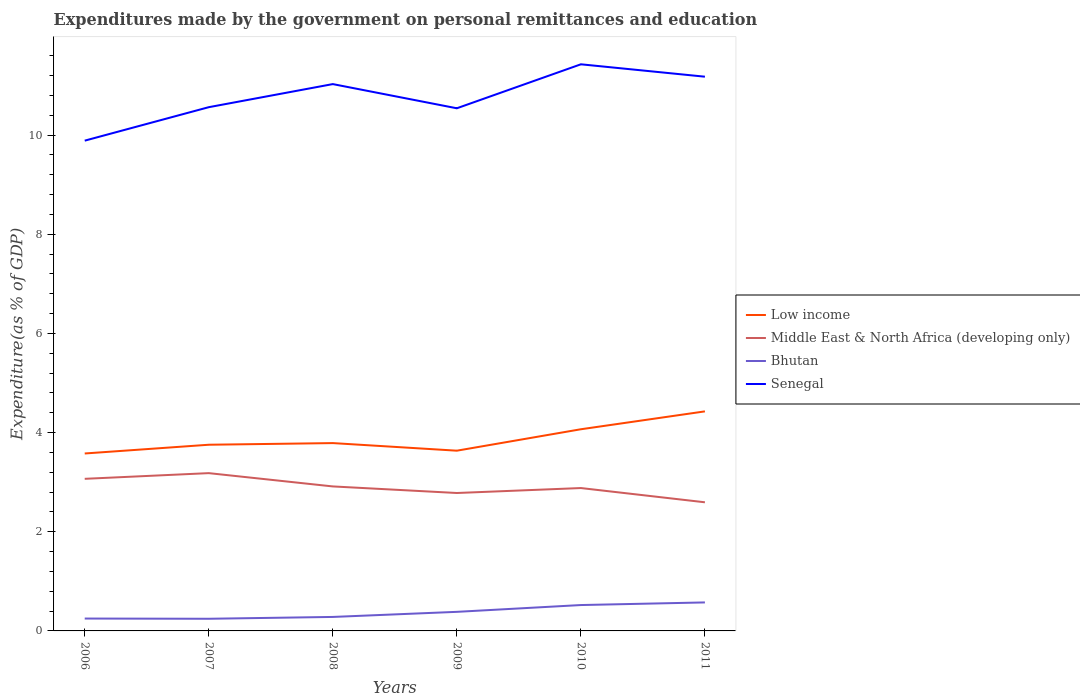Does the line corresponding to Middle East & North Africa (developing only) intersect with the line corresponding to Senegal?
Your answer should be very brief. No. Across all years, what is the maximum expenditures made by the government on personal remittances and education in Middle East & North Africa (developing only)?
Your answer should be very brief. 2.59. What is the total expenditures made by the government on personal remittances and education in Low income in the graph?
Offer a very short reply. -0.28. What is the difference between the highest and the second highest expenditures made by the government on personal remittances and education in Senegal?
Give a very brief answer. 1.54. What is the difference between the highest and the lowest expenditures made by the government on personal remittances and education in Middle East & North Africa (developing only)?
Your response must be concise. 3. How many years are there in the graph?
Your answer should be compact. 6. What is the difference between two consecutive major ticks on the Y-axis?
Your answer should be very brief. 2. Are the values on the major ticks of Y-axis written in scientific E-notation?
Your response must be concise. No. Does the graph contain grids?
Provide a short and direct response. No. How many legend labels are there?
Your answer should be very brief. 4. What is the title of the graph?
Provide a short and direct response. Expenditures made by the government on personal remittances and education. What is the label or title of the X-axis?
Give a very brief answer. Years. What is the label or title of the Y-axis?
Your response must be concise. Expenditure(as % of GDP). What is the Expenditure(as % of GDP) of Low income in 2006?
Offer a terse response. 3.58. What is the Expenditure(as % of GDP) in Middle East & North Africa (developing only) in 2006?
Your response must be concise. 3.07. What is the Expenditure(as % of GDP) of Bhutan in 2006?
Offer a very short reply. 0.25. What is the Expenditure(as % of GDP) in Senegal in 2006?
Keep it short and to the point. 9.89. What is the Expenditure(as % of GDP) in Low income in 2007?
Offer a terse response. 3.75. What is the Expenditure(as % of GDP) of Middle East & North Africa (developing only) in 2007?
Provide a succinct answer. 3.18. What is the Expenditure(as % of GDP) in Bhutan in 2007?
Your response must be concise. 0.25. What is the Expenditure(as % of GDP) of Senegal in 2007?
Your response must be concise. 10.56. What is the Expenditure(as % of GDP) of Low income in 2008?
Ensure brevity in your answer.  3.79. What is the Expenditure(as % of GDP) of Middle East & North Africa (developing only) in 2008?
Your response must be concise. 2.91. What is the Expenditure(as % of GDP) in Bhutan in 2008?
Ensure brevity in your answer.  0.28. What is the Expenditure(as % of GDP) in Senegal in 2008?
Give a very brief answer. 11.03. What is the Expenditure(as % of GDP) of Low income in 2009?
Keep it short and to the point. 3.63. What is the Expenditure(as % of GDP) of Middle East & North Africa (developing only) in 2009?
Ensure brevity in your answer.  2.78. What is the Expenditure(as % of GDP) of Bhutan in 2009?
Offer a terse response. 0.38. What is the Expenditure(as % of GDP) of Senegal in 2009?
Ensure brevity in your answer.  10.54. What is the Expenditure(as % of GDP) in Low income in 2010?
Provide a short and direct response. 4.07. What is the Expenditure(as % of GDP) of Middle East & North Africa (developing only) in 2010?
Provide a short and direct response. 2.88. What is the Expenditure(as % of GDP) of Bhutan in 2010?
Your answer should be compact. 0.52. What is the Expenditure(as % of GDP) in Senegal in 2010?
Your response must be concise. 11.43. What is the Expenditure(as % of GDP) of Low income in 2011?
Your answer should be very brief. 4.43. What is the Expenditure(as % of GDP) of Middle East & North Africa (developing only) in 2011?
Your answer should be very brief. 2.59. What is the Expenditure(as % of GDP) of Bhutan in 2011?
Ensure brevity in your answer.  0.57. What is the Expenditure(as % of GDP) in Senegal in 2011?
Make the answer very short. 11.18. Across all years, what is the maximum Expenditure(as % of GDP) in Low income?
Your answer should be compact. 4.43. Across all years, what is the maximum Expenditure(as % of GDP) in Middle East & North Africa (developing only)?
Give a very brief answer. 3.18. Across all years, what is the maximum Expenditure(as % of GDP) of Bhutan?
Ensure brevity in your answer.  0.57. Across all years, what is the maximum Expenditure(as % of GDP) of Senegal?
Provide a succinct answer. 11.43. Across all years, what is the minimum Expenditure(as % of GDP) in Low income?
Keep it short and to the point. 3.58. Across all years, what is the minimum Expenditure(as % of GDP) in Middle East & North Africa (developing only)?
Offer a very short reply. 2.59. Across all years, what is the minimum Expenditure(as % of GDP) in Bhutan?
Ensure brevity in your answer.  0.25. Across all years, what is the minimum Expenditure(as % of GDP) in Senegal?
Ensure brevity in your answer.  9.89. What is the total Expenditure(as % of GDP) in Low income in the graph?
Your answer should be compact. 23.25. What is the total Expenditure(as % of GDP) of Middle East & North Africa (developing only) in the graph?
Provide a short and direct response. 17.42. What is the total Expenditure(as % of GDP) of Bhutan in the graph?
Keep it short and to the point. 2.26. What is the total Expenditure(as % of GDP) of Senegal in the graph?
Your response must be concise. 64.62. What is the difference between the Expenditure(as % of GDP) of Low income in 2006 and that in 2007?
Your answer should be very brief. -0.18. What is the difference between the Expenditure(as % of GDP) of Middle East & North Africa (developing only) in 2006 and that in 2007?
Make the answer very short. -0.11. What is the difference between the Expenditure(as % of GDP) in Bhutan in 2006 and that in 2007?
Give a very brief answer. 0. What is the difference between the Expenditure(as % of GDP) of Senegal in 2006 and that in 2007?
Provide a short and direct response. -0.67. What is the difference between the Expenditure(as % of GDP) in Low income in 2006 and that in 2008?
Your response must be concise. -0.21. What is the difference between the Expenditure(as % of GDP) in Middle East & North Africa (developing only) in 2006 and that in 2008?
Provide a succinct answer. 0.15. What is the difference between the Expenditure(as % of GDP) of Bhutan in 2006 and that in 2008?
Your response must be concise. -0.03. What is the difference between the Expenditure(as % of GDP) of Senegal in 2006 and that in 2008?
Offer a terse response. -1.14. What is the difference between the Expenditure(as % of GDP) in Low income in 2006 and that in 2009?
Offer a very short reply. -0.06. What is the difference between the Expenditure(as % of GDP) in Middle East & North Africa (developing only) in 2006 and that in 2009?
Provide a succinct answer. 0.29. What is the difference between the Expenditure(as % of GDP) of Bhutan in 2006 and that in 2009?
Give a very brief answer. -0.14. What is the difference between the Expenditure(as % of GDP) of Senegal in 2006 and that in 2009?
Your answer should be very brief. -0.65. What is the difference between the Expenditure(as % of GDP) of Low income in 2006 and that in 2010?
Your answer should be compact. -0.49. What is the difference between the Expenditure(as % of GDP) of Middle East & North Africa (developing only) in 2006 and that in 2010?
Ensure brevity in your answer.  0.19. What is the difference between the Expenditure(as % of GDP) in Bhutan in 2006 and that in 2010?
Ensure brevity in your answer.  -0.27. What is the difference between the Expenditure(as % of GDP) in Senegal in 2006 and that in 2010?
Your answer should be very brief. -1.54. What is the difference between the Expenditure(as % of GDP) in Low income in 2006 and that in 2011?
Give a very brief answer. -0.85. What is the difference between the Expenditure(as % of GDP) of Middle East & North Africa (developing only) in 2006 and that in 2011?
Give a very brief answer. 0.47. What is the difference between the Expenditure(as % of GDP) of Bhutan in 2006 and that in 2011?
Keep it short and to the point. -0.33. What is the difference between the Expenditure(as % of GDP) in Senegal in 2006 and that in 2011?
Your answer should be very brief. -1.29. What is the difference between the Expenditure(as % of GDP) in Low income in 2007 and that in 2008?
Provide a short and direct response. -0.03. What is the difference between the Expenditure(as % of GDP) of Middle East & North Africa (developing only) in 2007 and that in 2008?
Keep it short and to the point. 0.27. What is the difference between the Expenditure(as % of GDP) in Bhutan in 2007 and that in 2008?
Your response must be concise. -0.04. What is the difference between the Expenditure(as % of GDP) of Senegal in 2007 and that in 2008?
Make the answer very short. -0.47. What is the difference between the Expenditure(as % of GDP) of Low income in 2007 and that in 2009?
Your answer should be compact. 0.12. What is the difference between the Expenditure(as % of GDP) in Middle East & North Africa (developing only) in 2007 and that in 2009?
Provide a short and direct response. 0.4. What is the difference between the Expenditure(as % of GDP) of Bhutan in 2007 and that in 2009?
Offer a very short reply. -0.14. What is the difference between the Expenditure(as % of GDP) in Senegal in 2007 and that in 2009?
Ensure brevity in your answer.  0.02. What is the difference between the Expenditure(as % of GDP) in Low income in 2007 and that in 2010?
Make the answer very short. -0.31. What is the difference between the Expenditure(as % of GDP) of Middle East & North Africa (developing only) in 2007 and that in 2010?
Your response must be concise. 0.3. What is the difference between the Expenditure(as % of GDP) in Bhutan in 2007 and that in 2010?
Make the answer very short. -0.28. What is the difference between the Expenditure(as % of GDP) in Senegal in 2007 and that in 2010?
Give a very brief answer. -0.86. What is the difference between the Expenditure(as % of GDP) of Low income in 2007 and that in 2011?
Keep it short and to the point. -0.67. What is the difference between the Expenditure(as % of GDP) of Middle East & North Africa (developing only) in 2007 and that in 2011?
Your answer should be compact. 0.59. What is the difference between the Expenditure(as % of GDP) in Bhutan in 2007 and that in 2011?
Offer a terse response. -0.33. What is the difference between the Expenditure(as % of GDP) in Senegal in 2007 and that in 2011?
Make the answer very short. -0.61. What is the difference between the Expenditure(as % of GDP) in Low income in 2008 and that in 2009?
Ensure brevity in your answer.  0.15. What is the difference between the Expenditure(as % of GDP) in Middle East & North Africa (developing only) in 2008 and that in 2009?
Provide a succinct answer. 0.13. What is the difference between the Expenditure(as % of GDP) of Bhutan in 2008 and that in 2009?
Your response must be concise. -0.1. What is the difference between the Expenditure(as % of GDP) of Senegal in 2008 and that in 2009?
Offer a terse response. 0.49. What is the difference between the Expenditure(as % of GDP) in Low income in 2008 and that in 2010?
Your answer should be very brief. -0.28. What is the difference between the Expenditure(as % of GDP) of Middle East & North Africa (developing only) in 2008 and that in 2010?
Your response must be concise. 0.03. What is the difference between the Expenditure(as % of GDP) of Bhutan in 2008 and that in 2010?
Provide a short and direct response. -0.24. What is the difference between the Expenditure(as % of GDP) of Senegal in 2008 and that in 2010?
Your response must be concise. -0.4. What is the difference between the Expenditure(as % of GDP) in Low income in 2008 and that in 2011?
Provide a succinct answer. -0.64. What is the difference between the Expenditure(as % of GDP) in Middle East & North Africa (developing only) in 2008 and that in 2011?
Keep it short and to the point. 0.32. What is the difference between the Expenditure(as % of GDP) in Bhutan in 2008 and that in 2011?
Keep it short and to the point. -0.29. What is the difference between the Expenditure(as % of GDP) of Senegal in 2008 and that in 2011?
Your response must be concise. -0.15. What is the difference between the Expenditure(as % of GDP) in Low income in 2009 and that in 2010?
Offer a very short reply. -0.43. What is the difference between the Expenditure(as % of GDP) of Middle East & North Africa (developing only) in 2009 and that in 2010?
Ensure brevity in your answer.  -0.1. What is the difference between the Expenditure(as % of GDP) of Bhutan in 2009 and that in 2010?
Give a very brief answer. -0.14. What is the difference between the Expenditure(as % of GDP) of Senegal in 2009 and that in 2010?
Offer a very short reply. -0.89. What is the difference between the Expenditure(as % of GDP) in Low income in 2009 and that in 2011?
Make the answer very short. -0.79. What is the difference between the Expenditure(as % of GDP) of Middle East & North Africa (developing only) in 2009 and that in 2011?
Ensure brevity in your answer.  0.19. What is the difference between the Expenditure(as % of GDP) in Bhutan in 2009 and that in 2011?
Provide a succinct answer. -0.19. What is the difference between the Expenditure(as % of GDP) of Senegal in 2009 and that in 2011?
Offer a very short reply. -0.64. What is the difference between the Expenditure(as % of GDP) in Low income in 2010 and that in 2011?
Provide a succinct answer. -0.36. What is the difference between the Expenditure(as % of GDP) of Middle East & North Africa (developing only) in 2010 and that in 2011?
Your answer should be compact. 0.29. What is the difference between the Expenditure(as % of GDP) of Bhutan in 2010 and that in 2011?
Make the answer very short. -0.05. What is the difference between the Expenditure(as % of GDP) in Low income in 2006 and the Expenditure(as % of GDP) in Middle East & North Africa (developing only) in 2007?
Offer a terse response. 0.4. What is the difference between the Expenditure(as % of GDP) of Low income in 2006 and the Expenditure(as % of GDP) of Bhutan in 2007?
Your response must be concise. 3.33. What is the difference between the Expenditure(as % of GDP) of Low income in 2006 and the Expenditure(as % of GDP) of Senegal in 2007?
Ensure brevity in your answer.  -6.98. What is the difference between the Expenditure(as % of GDP) of Middle East & North Africa (developing only) in 2006 and the Expenditure(as % of GDP) of Bhutan in 2007?
Your response must be concise. 2.82. What is the difference between the Expenditure(as % of GDP) of Middle East & North Africa (developing only) in 2006 and the Expenditure(as % of GDP) of Senegal in 2007?
Ensure brevity in your answer.  -7.49. What is the difference between the Expenditure(as % of GDP) of Bhutan in 2006 and the Expenditure(as % of GDP) of Senegal in 2007?
Offer a very short reply. -10.31. What is the difference between the Expenditure(as % of GDP) in Low income in 2006 and the Expenditure(as % of GDP) in Middle East & North Africa (developing only) in 2008?
Provide a short and direct response. 0.66. What is the difference between the Expenditure(as % of GDP) of Low income in 2006 and the Expenditure(as % of GDP) of Bhutan in 2008?
Give a very brief answer. 3.3. What is the difference between the Expenditure(as % of GDP) of Low income in 2006 and the Expenditure(as % of GDP) of Senegal in 2008?
Ensure brevity in your answer.  -7.45. What is the difference between the Expenditure(as % of GDP) in Middle East & North Africa (developing only) in 2006 and the Expenditure(as % of GDP) in Bhutan in 2008?
Provide a short and direct response. 2.79. What is the difference between the Expenditure(as % of GDP) of Middle East & North Africa (developing only) in 2006 and the Expenditure(as % of GDP) of Senegal in 2008?
Your response must be concise. -7.96. What is the difference between the Expenditure(as % of GDP) in Bhutan in 2006 and the Expenditure(as % of GDP) in Senegal in 2008?
Your response must be concise. -10.78. What is the difference between the Expenditure(as % of GDP) in Low income in 2006 and the Expenditure(as % of GDP) in Middle East & North Africa (developing only) in 2009?
Keep it short and to the point. 0.8. What is the difference between the Expenditure(as % of GDP) of Low income in 2006 and the Expenditure(as % of GDP) of Bhutan in 2009?
Your answer should be very brief. 3.19. What is the difference between the Expenditure(as % of GDP) of Low income in 2006 and the Expenditure(as % of GDP) of Senegal in 2009?
Your answer should be compact. -6.96. What is the difference between the Expenditure(as % of GDP) of Middle East & North Africa (developing only) in 2006 and the Expenditure(as % of GDP) of Bhutan in 2009?
Keep it short and to the point. 2.68. What is the difference between the Expenditure(as % of GDP) in Middle East & North Africa (developing only) in 2006 and the Expenditure(as % of GDP) in Senegal in 2009?
Provide a short and direct response. -7.47. What is the difference between the Expenditure(as % of GDP) of Bhutan in 2006 and the Expenditure(as % of GDP) of Senegal in 2009?
Make the answer very short. -10.29. What is the difference between the Expenditure(as % of GDP) of Low income in 2006 and the Expenditure(as % of GDP) of Middle East & North Africa (developing only) in 2010?
Offer a very short reply. 0.7. What is the difference between the Expenditure(as % of GDP) in Low income in 2006 and the Expenditure(as % of GDP) in Bhutan in 2010?
Give a very brief answer. 3.06. What is the difference between the Expenditure(as % of GDP) in Low income in 2006 and the Expenditure(as % of GDP) in Senegal in 2010?
Provide a succinct answer. -7.85. What is the difference between the Expenditure(as % of GDP) in Middle East & North Africa (developing only) in 2006 and the Expenditure(as % of GDP) in Bhutan in 2010?
Give a very brief answer. 2.55. What is the difference between the Expenditure(as % of GDP) of Middle East & North Africa (developing only) in 2006 and the Expenditure(as % of GDP) of Senegal in 2010?
Provide a succinct answer. -8.36. What is the difference between the Expenditure(as % of GDP) in Bhutan in 2006 and the Expenditure(as % of GDP) in Senegal in 2010?
Ensure brevity in your answer.  -11.18. What is the difference between the Expenditure(as % of GDP) in Low income in 2006 and the Expenditure(as % of GDP) in Middle East & North Africa (developing only) in 2011?
Keep it short and to the point. 0.98. What is the difference between the Expenditure(as % of GDP) in Low income in 2006 and the Expenditure(as % of GDP) in Bhutan in 2011?
Your answer should be compact. 3. What is the difference between the Expenditure(as % of GDP) of Low income in 2006 and the Expenditure(as % of GDP) of Senegal in 2011?
Keep it short and to the point. -7.6. What is the difference between the Expenditure(as % of GDP) of Middle East & North Africa (developing only) in 2006 and the Expenditure(as % of GDP) of Bhutan in 2011?
Your response must be concise. 2.49. What is the difference between the Expenditure(as % of GDP) of Middle East & North Africa (developing only) in 2006 and the Expenditure(as % of GDP) of Senegal in 2011?
Your answer should be very brief. -8.11. What is the difference between the Expenditure(as % of GDP) of Bhutan in 2006 and the Expenditure(as % of GDP) of Senegal in 2011?
Offer a terse response. -10.93. What is the difference between the Expenditure(as % of GDP) in Low income in 2007 and the Expenditure(as % of GDP) in Middle East & North Africa (developing only) in 2008?
Give a very brief answer. 0.84. What is the difference between the Expenditure(as % of GDP) of Low income in 2007 and the Expenditure(as % of GDP) of Bhutan in 2008?
Offer a very short reply. 3.47. What is the difference between the Expenditure(as % of GDP) in Low income in 2007 and the Expenditure(as % of GDP) in Senegal in 2008?
Your answer should be compact. -7.27. What is the difference between the Expenditure(as % of GDP) in Middle East & North Africa (developing only) in 2007 and the Expenditure(as % of GDP) in Bhutan in 2008?
Your answer should be very brief. 2.9. What is the difference between the Expenditure(as % of GDP) of Middle East & North Africa (developing only) in 2007 and the Expenditure(as % of GDP) of Senegal in 2008?
Your answer should be compact. -7.85. What is the difference between the Expenditure(as % of GDP) in Bhutan in 2007 and the Expenditure(as % of GDP) in Senegal in 2008?
Your answer should be compact. -10.78. What is the difference between the Expenditure(as % of GDP) in Low income in 2007 and the Expenditure(as % of GDP) in Middle East & North Africa (developing only) in 2009?
Your answer should be compact. 0.97. What is the difference between the Expenditure(as % of GDP) of Low income in 2007 and the Expenditure(as % of GDP) of Bhutan in 2009?
Make the answer very short. 3.37. What is the difference between the Expenditure(as % of GDP) in Low income in 2007 and the Expenditure(as % of GDP) in Senegal in 2009?
Your answer should be very brief. -6.78. What is the difference between the Expenditure(as % of GDP) in Middle East & North Africa (developing only) in 2007 and the Expenditure(as % of GDP) in Bhutan in 2009?
Give a very brief answer. 2.8. What is the difference between the Expenditure(as % of GDP) in Middle East & North Africa (developing only) in 2007 and the Expenditure(as % of GDP) in Senegal in 2009?
Provide a short and direct response. -7.36. What is the difference between the Expenditure(as % of GDP) in Bhutan in 2007 and the Expenditure(as % of GDP) in Senegal in 2009?
Your answer should be very brief. -10.29. What is the difference between the Expenditure(as % of GDP) of Low income in 2007 and the Expenditure(as % of GDP) of Middle East & North Africa (developing only) in 2010?
Provide a succinct answer. 0.87. What is the difference between the Expenditure(as % of GDP) in Low income in 2007 and the Expenditure(as % of GDP) in Bhutan in 2010?
Your answer should be compact. 3.23. What is the difference between the Expenditure(as % of GDP) of Low income in 2007 and the Expenditure(as % of GDP) of Senegal in 2010?
Keep it short and to the point. -7.67. What is the difference between the Expenditure(as % of GDP) of Middle East & North Africa (developing only) in 2007 and the Expenditure(as % of GDP) of Bhutan in 2010?
Offer a terse response. 2.66. What is the difference between the Expenditure(as % of GDP) in Middle East & North Africa (developing only) in 2007 and the Expenditure(as % of GDP) in Senegal in 2010?
Ensure brevity in your answer.  -8.24. What is the difference between the Expenditure(as % of GDP) in Bhutan in 2007 and the Expenditure(as % of GDP) in Senegal in 2010?
Keep it short and to the point. -11.18. What is the difference between the Expenditure(as % of GDP) in Low income in 2007 and the Expenditure(as % of GDP) in Middle East & North Africa (developing only) in 2011?
Make the answer very short. 1.16. What is the difference between the Expenditure(as % of GDP) of Low income in 2007 and the Expenditure(as % of GDP) of Bhutan in 2011?
Your answer should be very brief. 3.18. What is the difference between the Expenditure(as % of GDP) in Low income in 2007 and the Expenditure(as % of GDP) in Senegal in 2011?
Keep it short and to the point. -7.42. What is the difference between the Expenditure(as % of GDP) of Middle East & North Africa (developing only) in 2007 and the Expenditure(as % of GDP) of Bhutan in 2011?
Make the answer very short. 2.61. What is the difference between the Expenditure(as % of GDP) of Middle East & North Africa (developing only) in 2007 and the Expenditure(as % of GDP) of Senegal in 2011?
Make the answer very short. -7.99. What is the difference between the Expenditure(as % of GDP) of Bhutan in 2007 and the Expenditure(as % of GDP) of Senegal in 2011?
Your answer should be very brief. -10.93. What is the difference between the Expenditure(as % of GDP) of Low income in 2008 and the Expenditure(as % of GDP) of Middle East & North Africa (developing only) in 2009?
Your response must be concise. 1.01. What is the difference between the Expenditure(as % of GDP) in Low income in 2008 and the Expenditure(as % of GDP) in Bhutan in 2009?
Keep it short and to the point. 3.4. What is the difference between the Expenditure(as % of GDP) in Low income in 2008 and the Expenditure(as % of GDP) in Senegal in 2009?
Ensure brevity in your answer.  -6.75. What is the difference between the Expenditure(as % of GDP) in Middle East & North Africa (developing only) in 2008 and the Expenditure(as % of GDP) in Bhutan in 2009?
Provide a succinct answer. 2.53. What is the difference between the Expenditure(as % of GDP) of Middle East & North Africa (developing only) in 2008 and the Expenditure(as % of GDP) of Senegal in 2009?
Give a very brief answer. -7.63. What is the difference between the Expenditure(as % of GDP) of Bhutan in 2008 and the Expenditure(as % of GDP) of Senegal in 2009?
Your answer should be compact. -10.26. What is the difference between the Expenditure(as % of GDP) of Low income in 2008 and the Expenditure(as % of GDP) of Middle East & North Africa (developing only) in 2010?
Make the answer very short. 0.91. What is the difference between the Expenditure(as % of GDP) in Low income in 2008 and the Expenditure(as % of GDP) in Bhutan in 2010?
Your answer should be compact. 3.27. What is the difference between the Expenditure(as % of GDP) in Low income in 2008 and the Expenditure(as % of GDP) in Senegal in 2010?
Your response must be concise. -7.64. What is the difference between the Expenditure(as % of GDP) of Middle East & North Africa (developing only) in 2008 and the Expenditure(as % of GDP) of Bhutan in 2010?
Offer a terse response. 2.39. What is the difference between the Expenditure(as % of GDP) of Middle East & North Africa (developing only) in 2008 and the Expenditure(as % of GDP) of Senegal in 2010?
Make the answer very short. -8.51. What is the difference between the Expenditure(as % of GDP) of Bhutan in 2008 and the Expenditure(as % of GDP) of Senegal in 2010?
Offer a terse response. -11.14. What is the difference between the Expenditure(as % of GDP) in Low income in 2008 and the Expenditure(as % of GDP) in Middle East & North Africa (developing only) in 2011?
Keep it short and to the point. 1.19. What is the difference between the Expenditure(as % of GDP) in Low income in 2008 and the Expenditure(as % of GDP) in Bhutan in 2011?
Offer a very short reply. 3.21. What is the difference between the Expenditure(as % of GDP) of Low income in 2008 and the Expenditure(as % of GDP) of Senegal in 2011?
Your answer should be very brief. -7.39. What is the difference between the Expenditure(as % of GDP) in Middle East & North Africa (developing only) in 2008 and the Expenditure(as % of GDP) in Bhutan in 2011?
Your answer should be very brief. 2.34. What is the difference between the Expenditure(as % of GDP) in Middle East & North Africa (developing only) in 2008 and the Expenditure(as % of GDP) in Senegal in 2011?
Keep it short and to the point. -8.26. What is the difference between the Expenditure(as % of GDP) in Bhutan in 2008 and the Expenditure(as % of GDP) in Senegal in 2011?
Ensure brevity in your answer.  -10.89. What is the difference between the Expenditure(as % of GDP) of Low income in 2009 and the Expenditure(as % of GDP) of Middle East & North Africa (developing only) in 2010?
Offer a very short reply. 0.75. What is the difference between the Expenditure(as % of GDP) in Low income in 2009 and the Expenditure(as % of GDP) in Bhutan in 2010?
Your response must be concise. 3.11. What is the difference between the Expenditure(as % of GDP) of Low income in 2009 and the Expenditure(as % of GDP) of Senegal in 2010?
Provide a short and direct response. -7.79. What is the difference between the Expenditure(as % of GDP) of Middle East & North Africa (developing only) in 2009 and the Expenditure(as % of GDP) of Bhutan in 2010?
Ensure brevity in your answer.  2.26. What is the difference between the Expenditure(as % of GDP) of Middle East & North Africa (developing only) in 2009 and the Expenditure(as % of GDP) of Senegal in 2010?
Provide a short and direct response. -8.64. What is the difference between the Expenditure(as % of GDP) in Bhutan in 2009 and the Expenditure(as % of GDP) in Senegal in 2010?
Provide a succinct answer. -11.04. What is the difference between the Expenditure(as % of GDP) in Low income in 2009 and the Expenditure(as % of GDP) in Middle East & North Africa (developing only) in 2011?
Provide a succinct answer. 1.04. What is the difference between the Expenditure(as % of GDP) of Low income in 2009 and the Expenditure(as % of GDP) of Bhutan in 2011?
Your answer should be very brief. 3.06. What is the difference between the Expenditure(as % of GDP) of Low income in 2009 and the Expenditure(as % of GDP) of Senegal in 2011?
Your answer should be compact. -7.54. What is the difference between the Expenditure(as % of GDP) of Middle East & North Africa (developing only) in 2009 and the Expenditure(as % of GDP) of Bhutan in 2011?
Keep it short and to the point. 2.21. What is the difference between the Expenditure(as % of GDP) of Middle East & North Africa (developing only) in 2009 and the Expenditure(as % of GDP) of Senegal in 2011?
Keep it short and to the point. -8.39. What is the difference between the Expenditure(as % of GDP) of Bhutan in 2009 and the Expenditure(as % of GDP) of Senegal in 2011?
Your response must be concise. -10.79. What is the difference between the Expenditure(as % of GDP) of Low income in 2010 and the Expenditure(as % of GDP) of Middle East & North Africa (developing only) in 2011?
Keep it short and to the point. 1.47. What is the difference between the Expenditure(as % of GDP) of Low income in 2010 and the Expenditure(as % of GDP) of Bhutan in 2011?
Offer a terse response. 3.49. What is the difference between the Expenditure(as % of GDP) in Low income in 2010 and the Expenditure(as % of GDP) in Senegal in 2011?
Give a very brief answer. -7.11. What is the difference between the Expenditure(as % of GDP) in Middle East & North Africa (developing only) in 2010 and the Expenditure(as % of GDP) in Bhutan in 2011?
Your answer should be very brief. 2.31. What is the difference between the Expenditure(as % of GDP) in Middle East & North Africa (developing only) in 2010 and the Expenditure(as % of GDP) in Senegal in 2011?
Offer a terse response. -8.3. What is the difference between the Expenditure(as % of GDP) in Bhutan in 2010 and the Expenditure(as % of GDP) in Senegal in 2011?
Keep it short and to the point. -10.65. What is the average Expenditure(as % of GDP) in Low income per year?
Offer a terse response. 3.87. What is the average Expenditure(as % of GDP) of Middle East & North Africa (developing only) per year?
Your response must be concise. 2.9. What is the average Expenditure(as % of GDP) in Bhutan per year?
Make the answer very short. 0.38. What is the average Expenditure(as % of GDP) in Senegal per year?
Your answer should be compact. 10.77. In the year 2006, what is the difference between the Expenditure(as % of GDP) of Low income and Expenditure(as % of GDP) of Middle East & North Africa (developing only)?
Ensure brevity in your answer.  0.51. In the year 2006, what is the difference between the Expenditure(as % of GDP) in Low income and Expenditure(as % of GDP) in Bhutan?
Your answer should be compact. 3.33. In the year 2006, what is the difference between the Expenditure(as % of GDP) in Low income and Expenditure(as % of GDP) in Senegal?
Offer a terse response. -6.31. In the year 2006, what is the difference between the Expenditure(as % of GDP) of Middle East & North Africa (developing only) and Expenditure(as % of GDP) of Bhutan?
Provide a succinct answer. 2.82. In the year 2006, what is the difference between the Expenditure(as % of GDP) in Middle East & North Africa (developing only) and Expenditure(as % of GDP) in Senegal?
Provide a short and direct response. -6.82. In the year 2006, what is the difference between the Expenditure(as % of GDP) in Bhutan and Expenditure(as % of GDP) in Senegal?
Keep it short and to the point. -9.64. In the year 2007, what is the difference between the Expenditure(as % of GDP) in Low income and Expenditure(as % of GDP) in Middle East & North Africa (developing only)?
Offer a very short reply. 0.57. In the year 2007, what is the difference between the Expenditure(as % of GDP) of Low income and Expenditure(as % of GDP) of Bhutan?
Keep it short and to the point. 3.51. In the year 2007, what is the difference between the Expenditure(as % of GDP) in Low income and Expenditure(as % of GDP) in Senegal?
Make the answer very short. -6.81. In the year 2007, what is the difference between the Expenditure(as % of GDP) in Middle East & North Africa (developing only) and Expenditure(as % of GDP) in Bhutan?
Offer a very short reply. 2.94. In the year 2007, what is the difference between the Expenditure(as % of GDP) in Middle East & North Africa (developing only) and Expenditure(as % of GDP) in Senegal?
Offer a very short reply. -7.38. In the year 2007, what is the difference between the Expenditure(as % of GDP) of Bhutan and Expenditure(as % of GDP) of Senegal?
Your answer should be very brief. -10.32. In the year 2008, what is the difference between the Expenditure(as % of GDP) of Low income and Expenditure(as % of GDP) of Middle East & North Africa (developing only)?
Offer a very short reply. 0.87. In the year 2008, what is the difference between the Expenditure(as % of GDP) in Low income and Expenditure(as % of GDP) in Bhutan?
Your answer should be very brief. 3.51. In the year 2008, what is the difference between the Expenditure(as % of GDP) of Low income and Expenditure(as % of GDP) of Senegal?
Your answer should be very brief. -7.24. In the year 2008, what is the difference between the Expenditure(as % of GDP) in Middle East & North Africa (developing only) and Expenditure(as % of GDP) in Bhutan?
Your answer should be compact. 2.63. In the year 2008, what is the difference between the Expenditure(as % of GDP) of Middle East & North Africa (developing only) and Expenditure(as % of GDP) of Senegal?
Make the answer very short. -8.11. In the year 2008, what is the difference between the Expenditure(as % of GDP) of Bhutan and Expenditure(as % of GDP) of Senegal?
Make the answer very short. -10.74. In the year 2009, what is the difference between the Expenditure(as % of GDP) of Low income and Expenditure(as % of GDP) of Middle East & North Africa (developing only)?
Give a very brief answer. 0.85. In the year 2009, what is the difference between the Expenditure(as % of GDP) of Low income and Expenditure(as % of GDP) of Bhutan?
Offer a very short reply. 3.25. In the year 2009, what is the difference between the Expenditure(as % of GDP) of Low income and Expenditure(as % of GDP) of Senegal?
Provide a succinct answer. -6.9. In the year 2009, what is the difference between the Expenditure(as % of GDP) in Middle East & North Africa (developing only) and Expenditure(as % of GDP) in Bhutan?
Your answer should be compact. 2.4. In the year 2009, what is the difference between the Expenditure(as % of GDP) of Middle East & North Africa (developing only) and Expenditure(as % of GDP) of Senegal?
Ensure brevity in your answer.  -7.76. In the year 2009, what is the difference between the Expenditure(as % of GDP) in Bhutan and Expenditure(as % of GDP) in Senegal?
Ensure brevity in your answer.  -10.15. In the year 2010, what is the difference between the Expenditure(as % of GDP) in Low income and Expenditure(as % of GDP) in Middle East & North Africa (developing only)?
Offer a very short reply. 1.19. In the year 2010, what is the difference between the Expenditure(as % of GDP) in Low income and Expenditure(as % of GDP) in Bhutan?
Ensure brevity in your answer.  3.54. In the year 2010, what is the difference between the Expenditure(as % of GDP) in Low income and Expenditure(as % of GDP) in Senegal?
Ensure brevity in your answer.  -7.36. In the year 2010, what is the difference between the Expenditure(as % of GDP) in Middle East & North Africa (developing only) and Expenditure(as % of GDP) in Bhutan?
Provide a succinct answer. 2.36. In the year 2010, what is the difference between the Expenditure(as % of GDP) in Middle East & North Africa (developing only) and Expenditure(as % of GDP) in Senegal?
Provide a short and direct response. -8.55. In the year 2010, what is the difference between the Expenditure(as % of GDP) of Bhutan and Expenditure(as % of GDP) of Senegal?
Provide a succinct answer. -10.9. In the year 2011, what is the difference between the Expenditure(as % of GDP) in Low income and Expenditure(as % of GDP) in Middle East & North Africa (developing only)?
Provide a succinct answer. 1.83. In the year 2011, what is the difference between the Expenditure(as % of GDP) of Low income and Expenditure(as % of GDP) of Bhutan?
Provide a succinct answer. 3.85. In the year 2011, what is the difference between the Expenditure(as % of GDP) of Low income and Expenditure(as % of GDP) of Senegal?
Keep it short and to the point. -6.75. In the year 2011, what is the difference between the Expenditure(as % of GDP) in Middle East & North Africa (developing only) and Expenditure(as % of GDP) in Bhutan?
Offer a very short reply. 2.02. In the year 2011, what is the difference between the Expenditure(as % of GDP) of Middle East & North Africa (developing only) and Expenditure(as % of GDP) of Senegal?
Your response must be concise. -8.58. In the year 2011, what is the difference between the Expenditure(as % of GDP) in Bhutan and Expenditure(as % of GDP) in Senegal?
Your answer should be very brief. -10.6. What is the ratio of the Expenditure(as % of GDP) of Low income in 2006 to that in 2007?
Offer a terse response. 0.95. What is the ratio of the Expenditure(as % of GDP) of Middle East & North Africa (developing only) in 2006 to that in 2007?
Offer a terse response. 0.96. What is the ratio of the Expenditure(as % of GDP) in Bhutan in 2006 to that in 2007?
Your answer should be very brief. 1.02. What is the ratio of the Expenditure(as % of GDP) of Senegal in 2006 to that in 2007?
Your answer should be compact. 0.94. What is the ratio of the Expenditure(as % of GDP) of Low income in 2006 to that in 2008?
Your answer should be very brief. 0.94. What is the ratio of the Expenditure(as % of GDP) of Middle East & North Africa (developing only) in 2006 to that in 2008?
Your answer should be very brief. 1.05. What is the ratio of the Expenditure(as % of GDP) in Bhutan in 2006 to that in 2008?
Your response must be concise. 0.88. What is the ratio of the Expenditure(as % of GDP) in Senegal in 2006 to that in 2008?
Offer a terse response. 0.9. What is the ratio of the Expenditure(as % of GDP) of Low income in 2006 to that in 2009?
Make the answer very short. 0.98. What is the ratio of the Expenditure(as % of GDP) in Middle East & North Africa (developing only) in 2006 to that in 2009?
Give a very brief answer. 1.1. What is the ratio of the Expenditure(as % of GDP) in Bhutan in 2006 to that in 2009?
Keep it short and to the point. 0.65. What is the ratio of the Expenditure(as % of GDP) in Senegal in 2006 to that in 2009?
Keep it short and to the point. 0.94. What is the ratio of the Expenditure(as % of GDP) of Low income in 2006 to that in 2010?
Ensure brevity in your answer.  0.88. What is the ratio of the Expenditure(as % of GDP) of Middle East & North Africa (developing only) in 2006 to that in 2010?
Offer a terse response. 1.06. What is the ratio of the Expenditure(as % of GDP) in Bhutan in 2006 to that in 2010?
Ensure brevity in your answer.  0.48. What is the ratio of the Expenditure(as % of GDP) of Senegal in 2006 to that in 2010?
Offer a very short reply. 0.87. What is the ratio of the Expenditure(as % of GDP) of Low income in 2006 to that in 2011?
Provide a short and direct response. 0.81. What is the ratio of the Expenditure(as % of GDP) of Middle East & North Africa (developing only) in 2006 to that in 2011?
Your answer should be compact. 1.18. What is the ratio of the Expenditure(as % of GDP) in Bhutan in 2006 to that in 2011?
Your response must be concise. 0.43. What is the ratio of the Expenditure(as % of GDP) of Senegal in 2006 to that in 2011?
Offer a very short reply. 0.88. What is the ratio of the Expenditure(as % of GDP) in Middle East & North Africa (developing only) in 2007 to that in 2008?
Provide a short and direct response. 1.09. What is the ratio of the Expenditure(as % of GDP) in Bhutan in 2007 to that in 2008?
Your answer should be very brief. 0.87. What is the ratio of the Expenditure(as % of GDP) in Senegal in 2007 to that in 2008?
Offer a very short reply. 0.96. What is the ratio of the Expenditure(as % of GDP) in Low income in 2007 to that in 2009?
Give a very brief answer. 1.03. What is the ratio of the Expenditure(as % of GDP) in Middle East & North Africa (developing only) in 2007 to that in 2009?
Offer a terse response. 1.14. What is the ratio of the Expenditure(as % of GDP) of Bhutan in 2007 to that in 2009?
Your response must be concise. 0.64. What is the ratio of the Expenditure(as % of GDP) in Senegal in 2007 to that in 2009?
Provide a short and direct response. 1. What is the ratio of the Expenditure(as % of GDP) of Low income in 2007 to that in 2010?
Your answer should be compact. 0.92. What is the ratio of the Expenditure(as % of GDP) of Middle East & North Africa (developing only) in 2007 to that in 2010?
Give a very brief answer. 1.1. What is the ratio of the Expenditure(as % of GDP) in Bhutan in 2007 to that in 2010?
Offer a very short reply. 0.47. What is the ratio of the Expenditure(as % of GDP) of Senegal in 2007 to that in 2010?
Ensure brevity in your answer.  0.92. What is the ratio of the Expenditure(as % of GDP) of Low income in 2007 to that in 2011?
Your answer should be compact. 0.85. What is the ratio of the Expenditure(as % of GDP) of Middle East & North Africa (developing only) in 2007 to that in 2011?
Ensure brevity in your answer.  1.23. What is the ratio of the Expenditure(as % of GDP) of Bhutan in 2007 to that in 2011?
Provide a short and direct response. 0.43. What is the ratio of the Expenditure(as % of GDP) of Senegal in 2007 to that in 2011?
Provide a succinct answer. 0.94. What is the ratio of the Expenditure(as % of GDP) of Low income in 2008 to that in 2009?
Ensure brevity in your answer.  1.04. What is the ratio of the Expenditure(as % of GDP) of Middle East & North Africa (developing only) in 2008 to that in 2009?
Keep it short and to the point. 1.05. What is the ratio of the Expenditure(as % of GDP) of Bhutan in 2008 to that in 2009?
Make the answer very short. 0.73. What is the ratio of the Expenditure(as % of GDP) of Senegal in 2008 to that in 2009?
Make the answer very short. 1.05. What is the ratio of the Expenditure(as % of GDP) of Low income in 2008 to that in 2010?
Your answer should be compact. 0.93. What is the ratio of the Expenditure(as % of GDP) in Middle East & North Africa (developing only) in 2008 to that in 2010?
Ensure brevity in your answer.  1.01. What is the ratio of the Expenditure(as % of GDP) in Bhutan in 2008 to that in 2010?
Offer a very short reply. 0.54. What is the ratio of the Expenditure(as % of GDP) in Senegal in 2008 to that in 2010?
Ensure brevity in your answer.  0.97. What is the ratio of the Expenditure(as % of GDP) of Low income in 2008 to that in 2011?
Your response must be concise. 0.86. What is the ratio of the Expenditure(as % of GDP) in Middle East & North Africa (developing only) in 2008 to that in 2011?
Your answer should be compact. 1.12. What is the ratio of the Expenditure(as % of GDP) of Bhutan in 2008 to that in 2011?
Provide a succinct answer. 0.49. What is the ratio of the Expenditure(as % of GDP) in Senegal in 2008 to that in 2011?
Provide a short and direct response. 0.99. What is the ratio of the Expenditure(as % of GDP) in Low income in 2009 to that in 2010?
Provide a short and direct response. 0.89. What is the ratio of the Expenditure(as % of GDP) of Middle East & North Africa (developing only) in 2009 to that in 2010?
Give a very brief answer. 0.97. What is the ratio of the Expenditure(as % of GDP) of Bhutan in 2009 to that in 2010?
Ensure brevity in your answer.  0.74. What is the ratio of the Expenditure(as % of GDP) in Senegal in 2009 to that in 2010?
Your answer should be very brief. 0.92. What is the ratio of the Expenditure(as % of GDP) of Low income in 2009 to that in 2011?
Your response must be concise. 0.82. What is the ratio of the Expenditure(as % of GDP) in Middle East & North Africa (developing only) in 2009 to that in 2011?
Provide a succinct answer. 1.07. What is the ratio of the Expenditure(as % of GDP) in Bhutan in 2009 to that in 2011?
Provide a short and direct response. 0.67. What is the ratio of the Expenditure(as % of GDP) in Senegal in 2009 to that in 2011?
Your answer should be very brief. 0.94. What is the ratio of the Expenditure(as % of GDP) of Low income in 2010 to that in 2011?
Offer a terse response. 0.92. What is the ratio of the Expenditure(as % of GDP) of Middle East & North Africa (developing only) in 2010 to that in 2011?
Make the answer very short. 1.11. What is the ratio of the Expenditure(as % of GDP) in Bhutan in 2010 to that in 2011?
Ensure brevity in your answer.  0.91. What is the ratio of the Expenditure(as % of GDP) of Senegal in 2010 to that in 2011?
Ensure brevity in your answer.  1.02. What is the difference between the highest and the second highest Expenditure(as % of GDP) in Low income?
Ensure brevity in your answer.  0.36. What is the difference between the highest and the second highest Expenditure(as % of GDP) of Middle East & North Africa (developing only)?
Your answer should be compact. 0.11. What is the difference between the highest and the second highest Expenditure(as % of GDP) in Bhutan?
Offer a very short reply. 0.05. What is the difference between the highest and the second highest Expenditure(as % of GDP) in Senegal?
Provide a short and direct response. 0.25. What is the difference between the highest and the lowest Expenditure(as % of GDP) in Low income?
Make the answer very short. 0.85. What is the difference between the highest and the lowest Expenditure(as % of GDP) of Middle East & North Africa (developing only)?
Provide a succinct answer. 0.59. What is the difference between the highest and the lowest Expenditure(as % of GDP) in Bhutan?
Your answer should be compact. 0.33. What is the difference between the highest and the lowest Expenditure(as % of GDP) of Senegal?
Your answer should be compact. 1.54. 